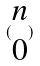Convert formula to latex. <formula><loc_0><loc_0><loc_500><loc_500>( \begin{matrix} n \\ 0 \end{matrix} )</formula> 